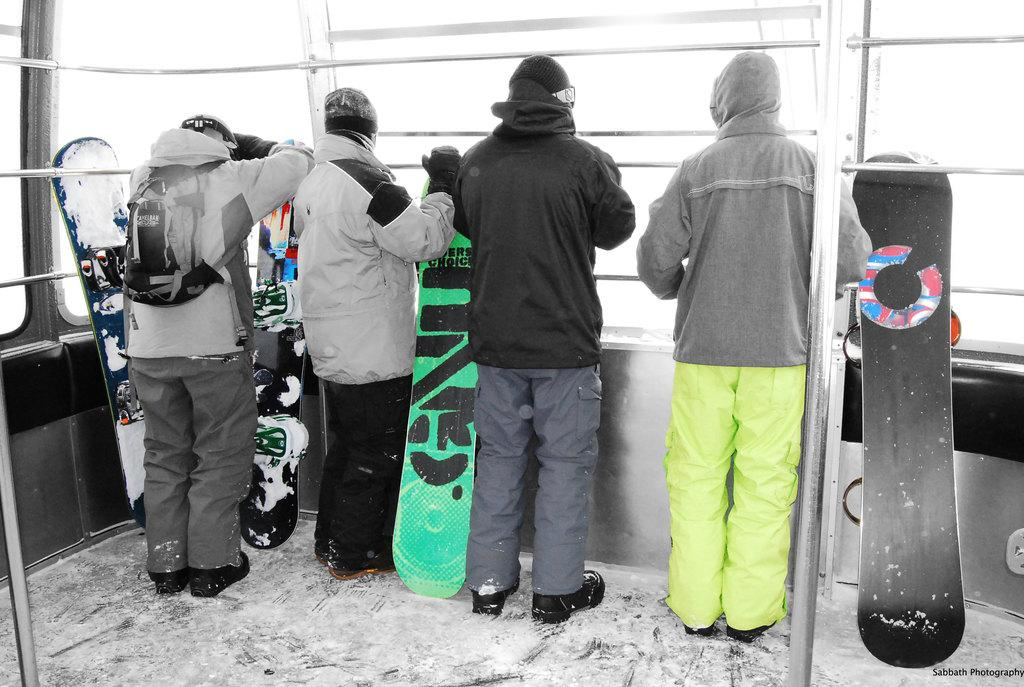How many people are in the image? There is a group of people in the image. What are the people doing in the image? The people are peeping from a window. What can be inferred about the location of the image based on the facts? The image appears to be set in a snowy area. What unit of measurement is being used to measure the slip in the image? There is no slip present in the image, so no unit of measurement is being used. 